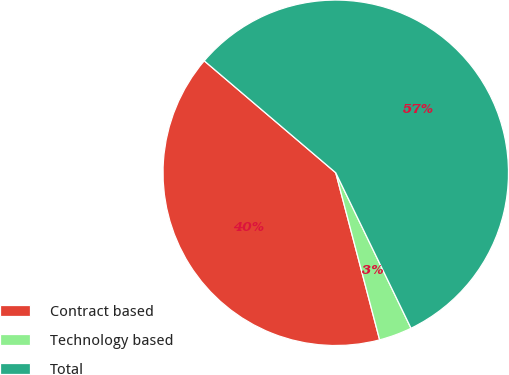Convert chart. <chart><loc_0><loc_0><loc_500><loc_500><pie_chart><fcel>Contract based<fcel>Technology based<fcel>Total<nl><fcel>40.31%<fcel>3.09%<fcel>56.6%<nl></chart> 